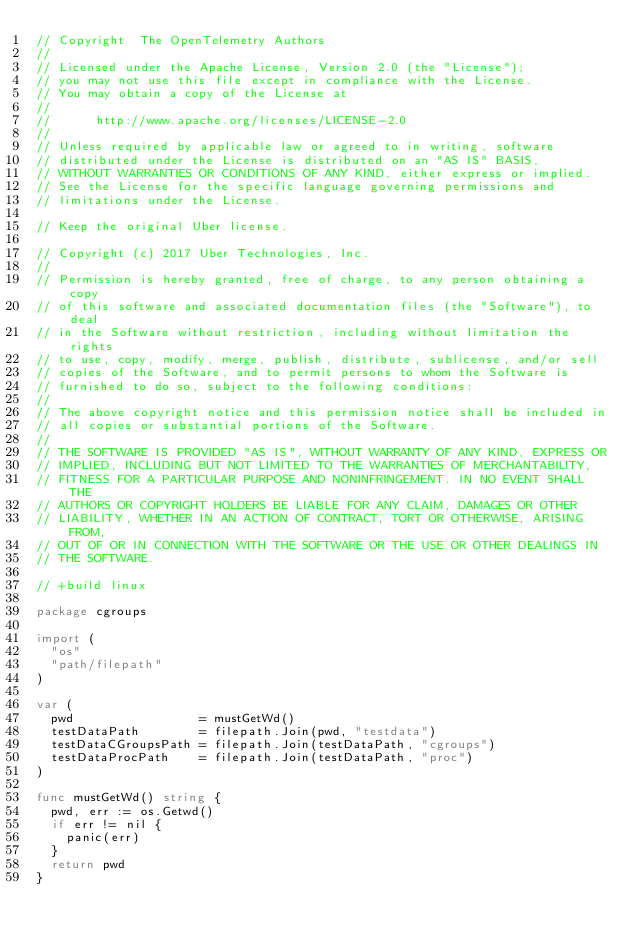Convert code to text. <code><loc_0><loc_0><loc_500><loc_500><_Go_>// Copyright  The OpenTelemetry Authors
//
// Licensed under the Apache License, Version 2.0 (the "License");
// you may not use this file except in compliance with the License.
// You may obtain a copy of the License at
//
//      http://www.apache.org/licenses/LICENSE-2.0
//
// Unless required by applicable law or agreed to in writing, software
// distributed under the License is distributed on an "AS IS" BASIS,
// WITHOUT WARRANTIES OR CONDITIONS OF ANY KIND, either express or implied.
// See the License for the specific language governing permissions and
// limitations under the License.

// Keep the original Uber license.

// Copyright (c) 2017 Uber Technologies, Inc.
//
// Permission is hereby granted, free of charge, to any person obtaining a copy
// of this software and associated documentation files (the "Software"), to deal
// in the Software without restriction, including without limitation the rights
// to use, copy, modify, merge, publish, distribute, sublicense, and/or sell
// copies of the Software, and to permit persons to whom the Software is
// furnished to do so, subject to the following conditions:
//
// The above copyright notice and this permission notice shall be included in
// all copies or substantial portions of the Software.
//
// THE SOFTWARE IS PROVIDED "AS IS", WITHOUT WARRANTY OF ANY KIND, EXPRESS OR
// IMPLIED, INCLUDING BUT NOT LIMITED TO THE WARRANTIES OF MERCHANTABILITY,
// FITNESS FOR A PARTICULAR PURPOSE AND NONINFRINGEMENT. IN NO EVENT SHALL THE
// AUTHORS OR COPYRIGHT HOLDERS BE LIABLE FOR ANY CLAIM, DAMAGES OR OTHER
// LIABILITY, WHETHER IN AN ACTION OF CONTRACT, TORT OR OTHERWISE, ARISING FROM,
// OUT OF OR IN CONNECTION WITH THE SOFTWARE OR THE USE OR OTHER DEALINGS IN
// THE SOFTWARE.

// +build linux

package cgroups

import (
	"os"
	"path/filepath"
)

var (
	pwd                 = mustGetWd()
	testDataPath        = filepath.Join(pwd, "testdata")
	testDataCGroupsPath = filepath.Join(testDataPath, "cgroups")
	testDataProcPath    = filepath.Join(testDataPath, "proc")
)

func mustGetWd() string {
	pwd, err := os.Getwd()
	if err != nil {
		panic(err)
	}
	return pwd
}
</code> 